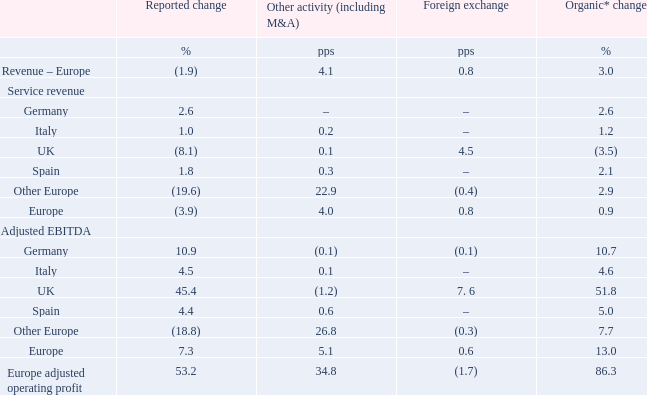European revenue decreased by 1.9%. Foreign exchange movements contributed a 0.8 percentage point negative impact and the deconsolidation of Vodafone Netherlands contributed a 4.1 percentage point negative impact, offset by 3.0% organic growth. Service revenue increased by 0.9%* or 0.6%* excluding a legal settlement in Germany in Q4, driven by strong fixed customer growth and the benefit of the Group’s “more-for-more” mobile propositions in several markets, which offset increased regulatory headwinds following the implementation of the EU’s “Roam Like At Home” policy in June and the impact of the introduction of handset financing in the UK. Excluding regulation and UK handset financing, as well as a legal settlement in Germany in Q4, service revenue growth was 2.0%* (Q3: 1.9%*, Q4: 1.7%*).
Adjusted EBITDA increased 7.3%, including a 5.1 percentage point negative impact from the deconsolidation of Vodafone Netherlands and a 0.6 percentage point negative impact from foreign exchange movements. On an organic basis, adjusted EBITDA increased 13.0%*, supported by the benefit of the introduction of handset financing in the UK, regulatory settlements in the UK and a legal settlement in Germany. Excluding these items, as well as the net impact of roaming, adjusted EBITDA grew by 7.9*, reflecting operating leverage and tight cost control through our “Fit for Growth” programme.
Adjusted EBIT increased by 86.3%*, reflecting strong adjusted EBITDA growth and stable depreciation and amortisation expenses.
Which countries does the Adjusted EBITDA comprise of? Germany, italy, uk, spain, other europe, europe. What countries does the Service Revenue include? Germany, italy, uk, spain, other europe, europe. What is the reported change in revenue - europe?
Answer scale should be: percent. (1.9). Between Germany and Italy, which one has a higher organic change? 2.6% > 1.2%
Answer: germany. How many percent of organic change in Europe adjusted operating profit is the organic change in Italy EBITDA?
Answer scale should be: percent. 4.6/86.3
Answer: 5.33. Between Germany and Italy, which has higher reported change in adjusted EBITDA? 10.9>4.5
Answer: germany. 